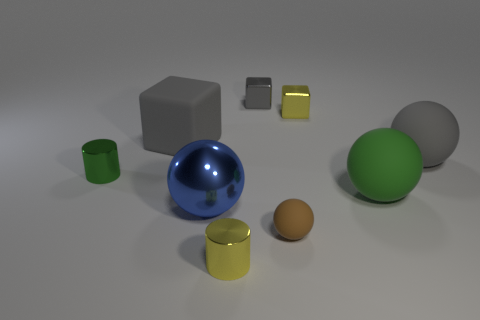Subtract all big blue shiny balls. How many balls are left? 3 Add 1 small brown rubber balls. How many objects exist? 10 Subtract all yellow cylinders. How many gray blocks are left? 2 Subtract all cylinders. How many objects are left? 7 Subtract 2 balls. How many balls are left? 2 Subtract all yellow blocks. How many blocks are left? 2 Subtract 0 brown cubes. How many objects are left? 9 Subtract all cyan blocks. Subtract all blue balls. How many blocks are left? 3 Subtract all large gray cylinders. Subtract all blue things. How many objects are left? 8 Add 3 big metal spheres. How many big metal spheres are left? 4 